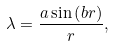<formula> <loc_0><loc_0><loc_500><loc_500>\lambda = \frac { a \sin \left ( b r \right ) } { r } ,</formula> 